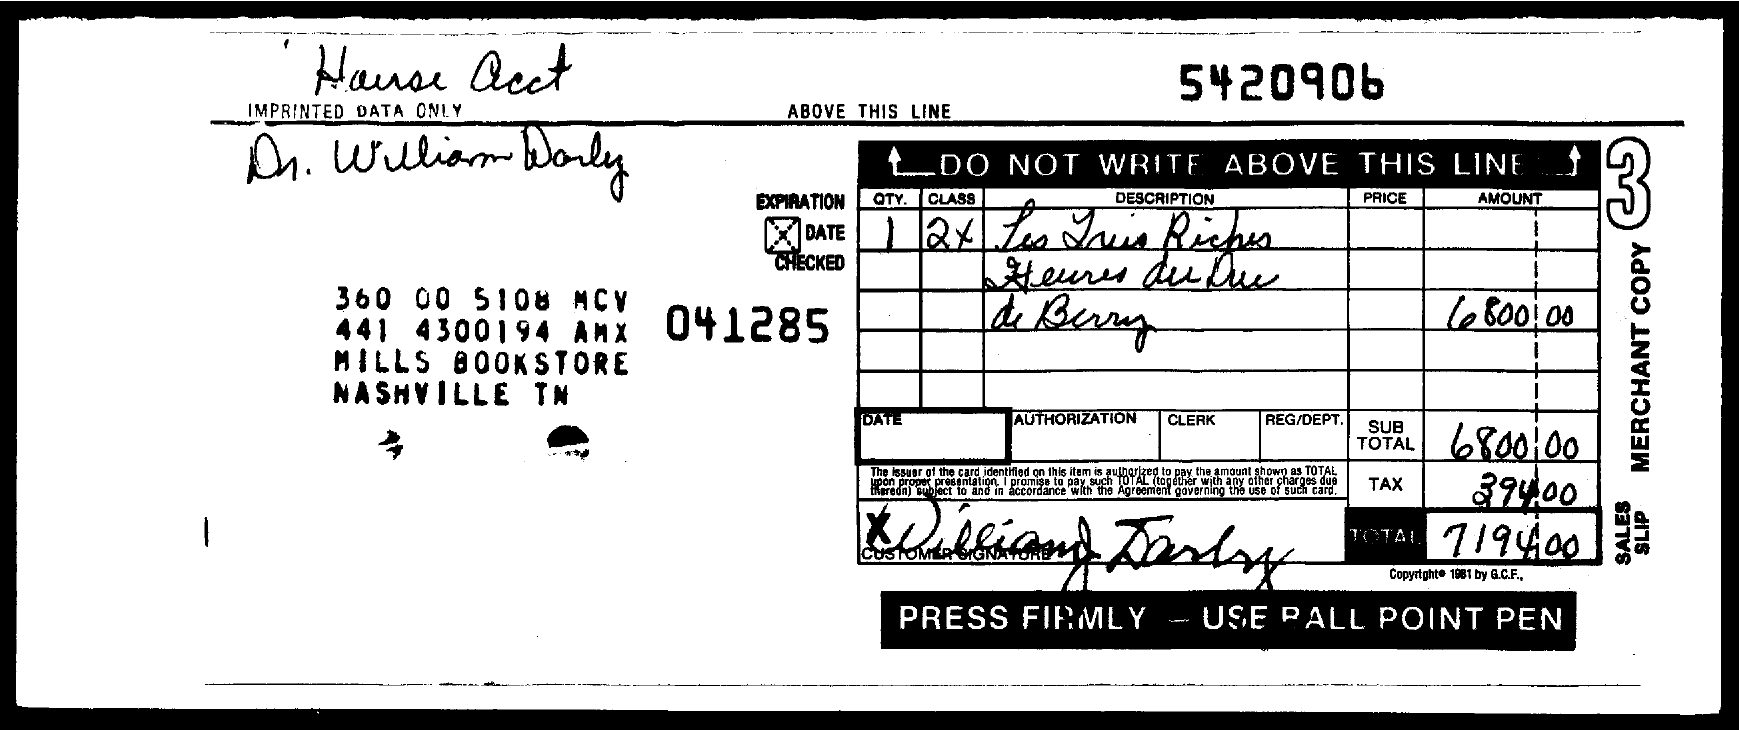Highlight a few significant elements in this photo. The number at the top of the document is 5420906. 